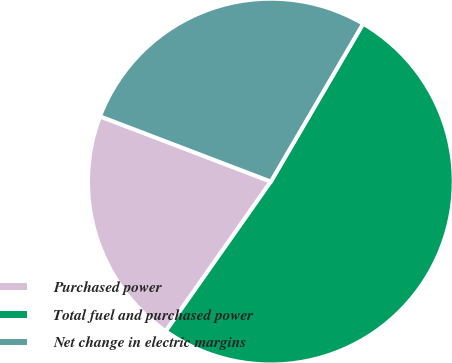Convert chart. <chart><loc_0><loc_0><loc_500><loc_500><pie_chart><fcel>Purchased power<fcel>Total fuel and purchased power<fcel>Net change in electric margins<nl><fcel>21.06%<fcel>51.33%<fcel>27.61%<nl></chart> 